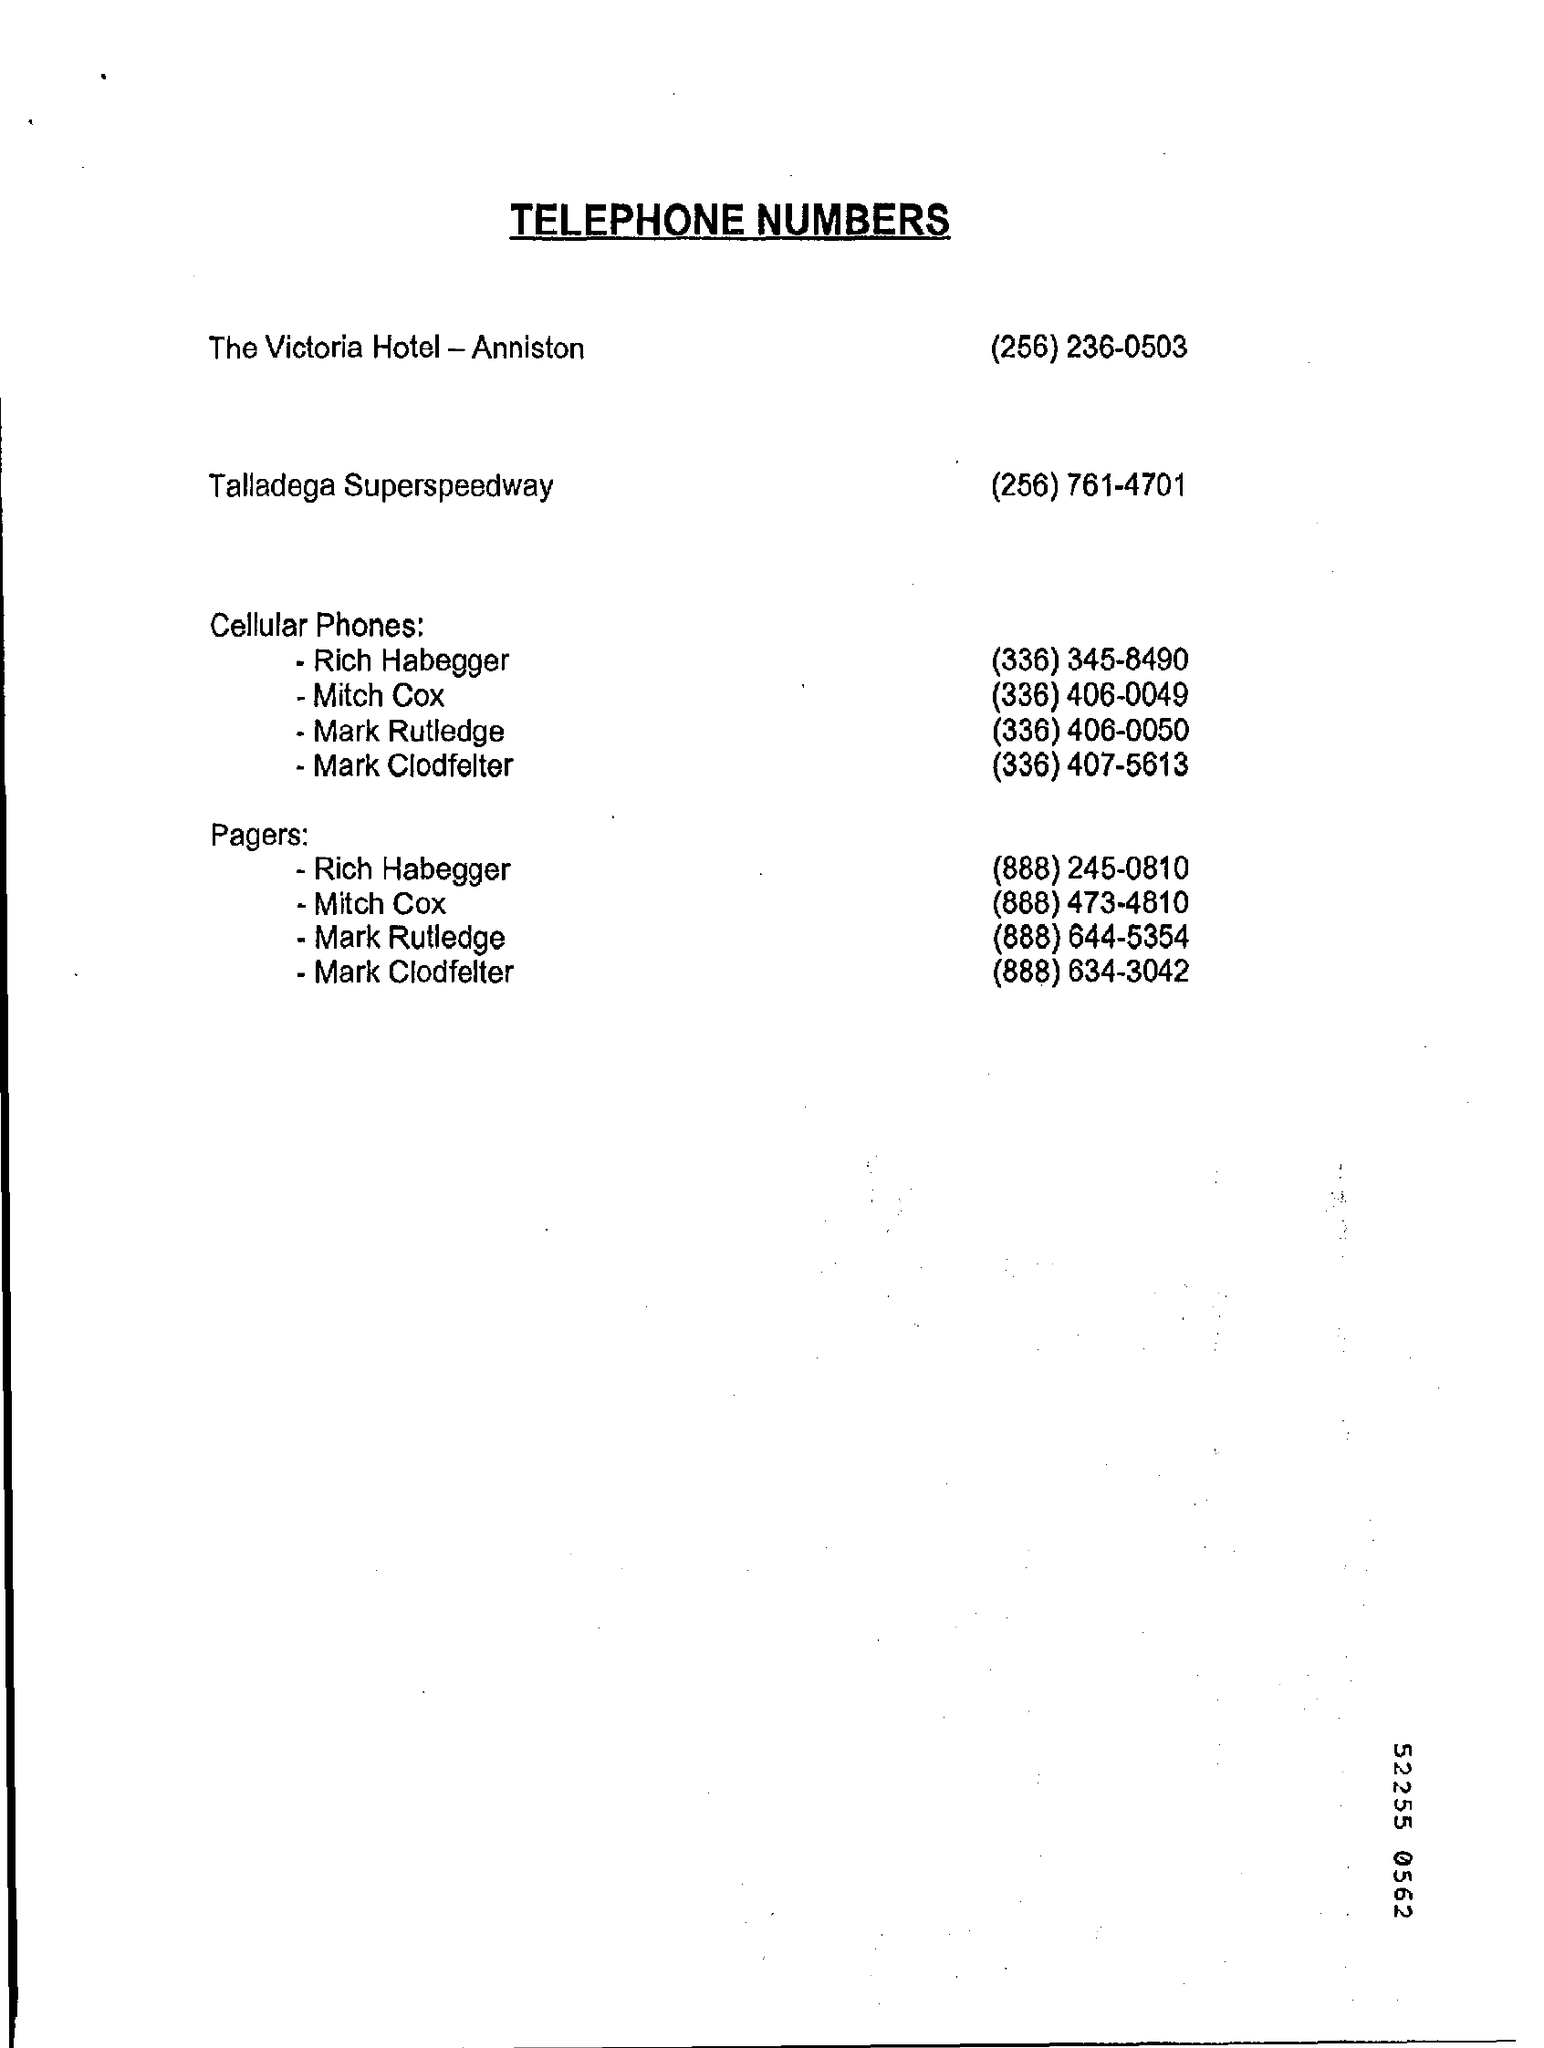Draw attention to some important aspects in this diagram. The title of this document is Telephone Numbers. 